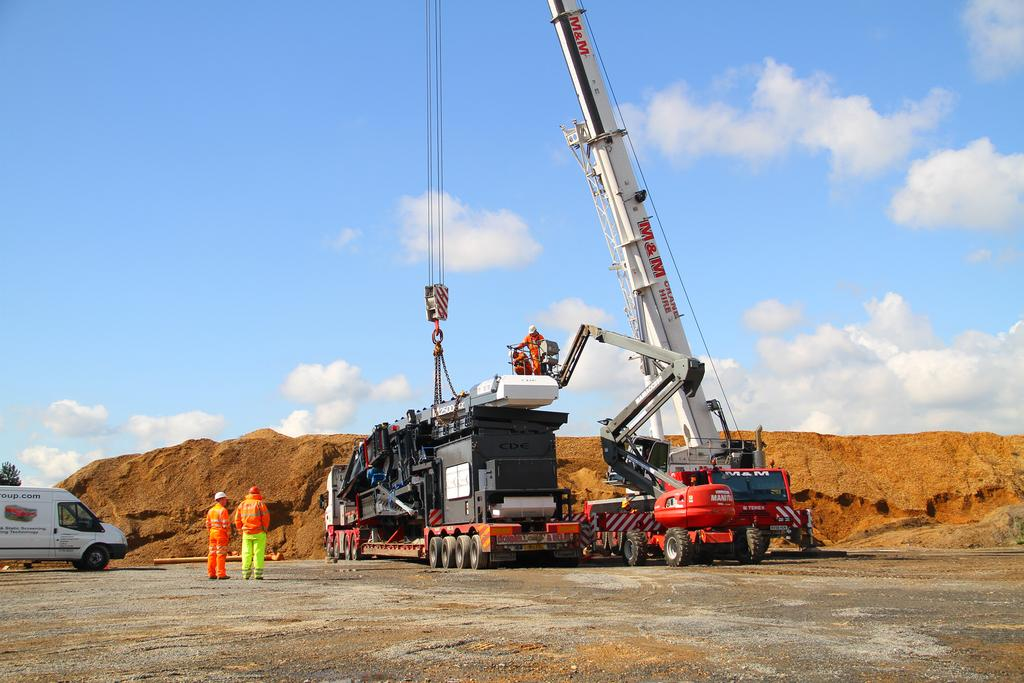What types of objects or subjects can be seen in the image? There are people, vehicles, a crane, ropes, a chain, a tree, clouds, and the sky visible in the image. Can you describe the vehicles in the image? The vehicles in the image are not specified, but they are present. What is the crane used for in the image? The purpose of the crane in the image is not clear, but it is a piece of machinery used for lifting and moving heavy objects. What is the tree's location in the image? The tree is located in the image, but its exact position is not specified. What is visible in the sky in the image? Clouds and the sky are visible in the image. What type of food is being served at the police club in the image? There is no mention of food, police, or a club in the image. The image contains people, vehicles, a crane, ropes, a chain, a tree, clouds, and the sky. 